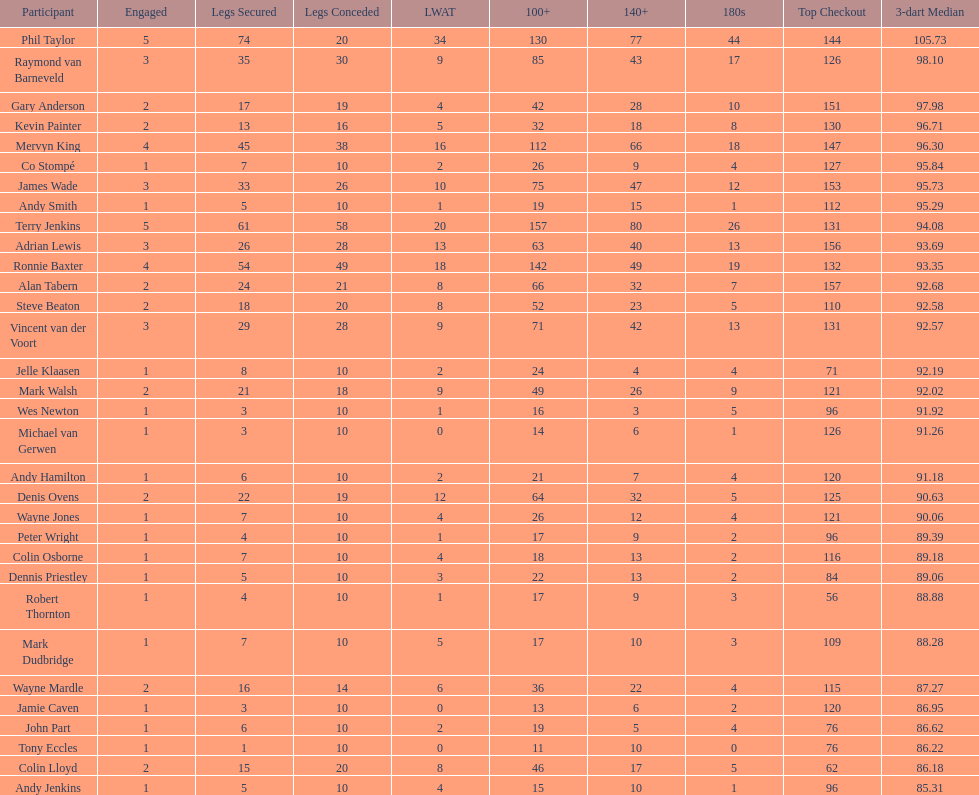Was andy smith or kevin painter's 3-dart average 96.71? Kevin Painter. 